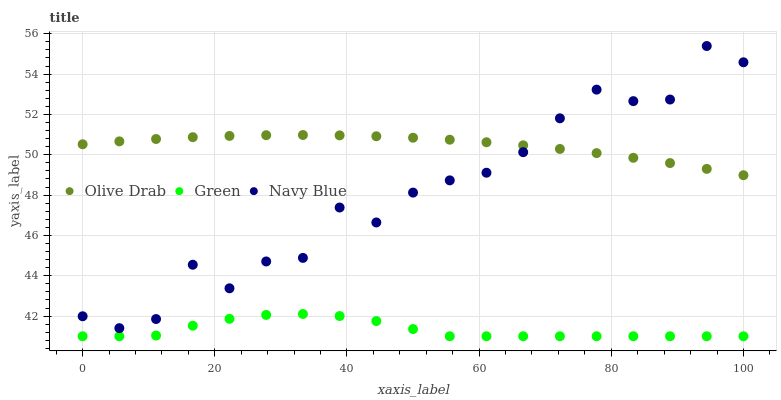Does Green have the minimum area under the curve?
Answer yes or no. Yes. Does Olive Drab have the maximum area under the curve?
Answer yes or no. Yes. Does Olive Drab have the minimum area under the curve?
Answer yes or no. No. Does Green have the maximum area under the curve?
Answer yes or no. No. Is Olive Drab the smoothest?
Answer yes or no. Yes. Is Navy Blue the roughest?
Answer yes or no. Yes. Is Green the smoothest?
Answer yes or no. No. Is Green the roughest?
Answer yes or no. No. Does Green have the lowest value?
Answer yes or no. Yes. Does Olive Drab have the lowest value?
Answer yes or no. No. Does Navy Blue have the highest value?
Answer yes or no. Yes. Does Olive Drab have the highest value?
Answer yes or no. No. Is Green less than Olive Drab?
Answer yes or no. Yes. Is Olive Drab greater than Green?
Answer yes or no. Yes. Does Olive Drab intersect Navy Blue?
Answer yes or no. Yes. Is Olive Drab less than Navy Blue?
Answer yes or no. No. Is Olive Drab greater than Navy Blue?
Answer yes or no. No. Does Green intersect Olive Drab?
Answer yes or no. No. 